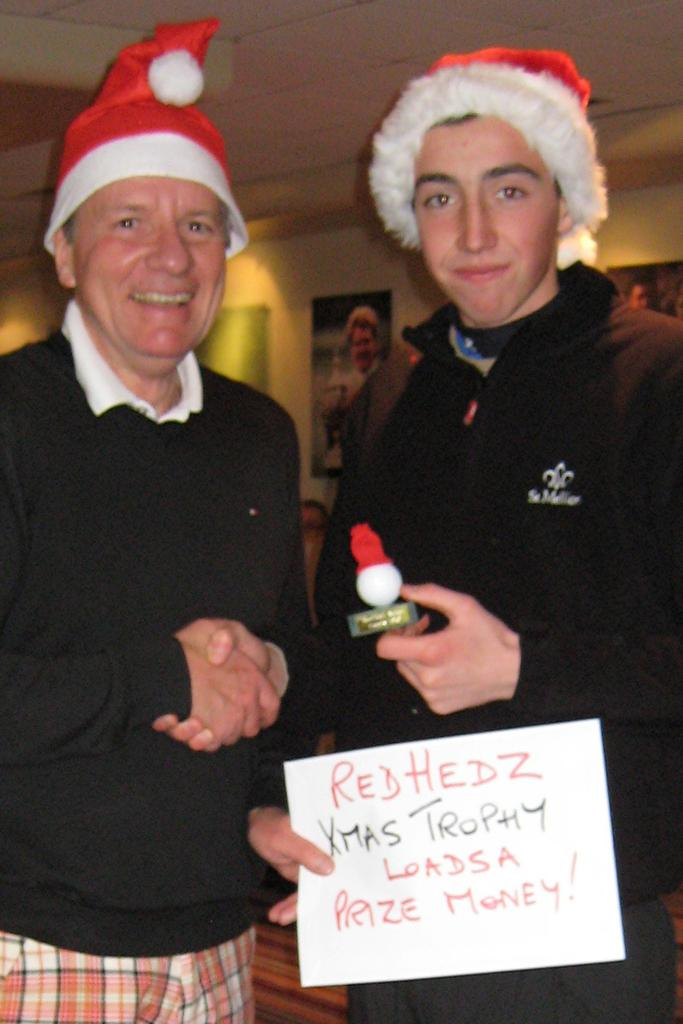How many people are in the image? There are two persons in the image. What are the two persons wearing? Both persons are wearing black dresses and Christmas caps. What are the two persons doing in the image? The two persons are shaking hands and smiling. What can be seen in the background of the image? There are pictures on the wall in the background. What type of lizards can be seen in the image? There are no lizards present in the image. How does the harmony between the two persons affect their mindset in the image? The provided facts do not mention anything about harmony or the mindset of the two persons, so we cannot answer this question based on the image. 